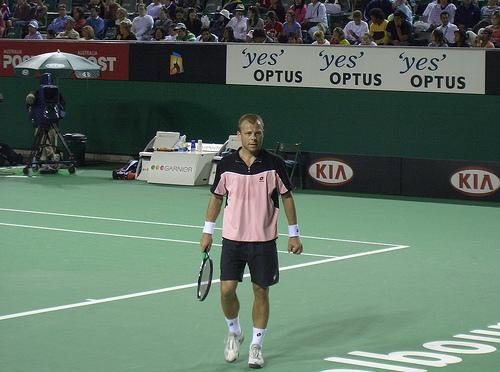What type of equipment is being used by the person capturing the image, and what protection measures can be observed? The person capturing the image is using a camera with a green and white umbrella over it for protection from the sun or rain. What is the tennis player's stance, and what item is he holding in his hand? The tennis player is holding a black tennis racket in his hand and appears to be in a ready-to-play stance. Are there any spectators in the image? If so, describe their appearance. Yes, there are people sitting in the stands, and one spectator is wearing a yellow and black shirt. How many advertisements can be seen in the image, and what companies are being advertised? There are three advertisements - a red Kia sign, a white banner that says "Yes Optus", and a red and white advertisement with unknown details. Mention the various objects that are part of the tennis court environment in the image. White markings on the court, part of a line, part of a field, part of a short, part of a court, part of a banner, edge of a short, edge of a racket, and dark green barrier. Identify the primary color of the playing ground and the type of sport being played. The playing ground is blue in color and the sport being played is tennis. What type of clothing is the tennis player wearing, and what colors are present in their outfit? The tennis player is wearing a short-sleeved shirt that is pink and black and has shorts that are black in color. Describe any accessories worn by the tennis player and their purpose in the game. The tennis player has a white wristband to absorb sweat and is wearing tennis shoes for appropriate support and grip during the game. Name any objects that could be considered as waste disposal items in the image and their characteristics. There is a green garbage can with a lid present. Discuss any visible safety features or warning signs in the background of the image. There is a small yellow sign with an image of a person on it, which may serve as a safety warning or guidance for people in the area. What color is the spectator's shirt located at X:367 Y:7? Yellow and black Is the umbrella in the image purple with yellow stripes? There is no purple umbrella with yellow stripes mentioned in the provided information, but there is a green and white umbrella. What color are the shoes and socks of the tennis player? White Are there any anomalies or unusual objects detected in the image? No Is there a basketball player wearing a blue and orange jersey in the image? The mentioned person is a tennis player wearing a pink and black shirt, not a basketball player with a blue and orange jersey. Find the coordinates and dimensions of the green and white umbrella in the image. X:12 Y:44 Width:92 Height:92 Identify the areas in the image where people are sitting in the stands. X:146 Y:4 Width:275 Height:275 Find the position and size of the object that represents a part of a court. X:345 Y:290 Width:52 Height:52 Is the advertisement behind the man showing a car with blue color? The advertisement is red and white, with a red Kia sign, not a blue car. Is there a camera with an umbrella over it in the image? If so, provide the coordinates and dimensions. Yes, X:16 Y:43 Width:87 Height:87 Can you find a spectator wearing a green and purple shirt? There is a spectator in a yellow and black shirt, not a green and purple one. Which company's sign can be seen in red color in the image? Kia Identify the different colors of the shorts around the man's waist. Black and white How many distinct objects are mentioned in the given image information? 30 Is there a red and white advertisement in the image? If yes, provide its location and size. Yes, X:303 Y:148 Width:59 Height:59 What color is the tennis racket in the man's hand? Black Describe the attributes of the tennis player's shirt in the image. Black and pink, short-sleeved What is the dominant sentiment conveyed by the image? Competitive sports atmosphere In which area of the image can a white wrist band be found? X:194 Y:210 Width:28 Height:28 Is the tennis court covered with red markings? The tennis court has white markings, not red ones. Read the text on the white banner in the image. Yes Optus Identify any objects that seem to be interacting or related in the image. Tennis player and racket, Umbrella and camera, Man and green garbage can What is the color of the playing ground in the image? Blue Which object in the image has the largest dimensions? Dark green barrier, X:3 Y:76 Width:493 Height:493 How would you describe the quality of the image based on the available information? Good and detailed Does the tennis player have a white tennis racket in his hand? The tennis player holds a black tennis racket, not a white one. 